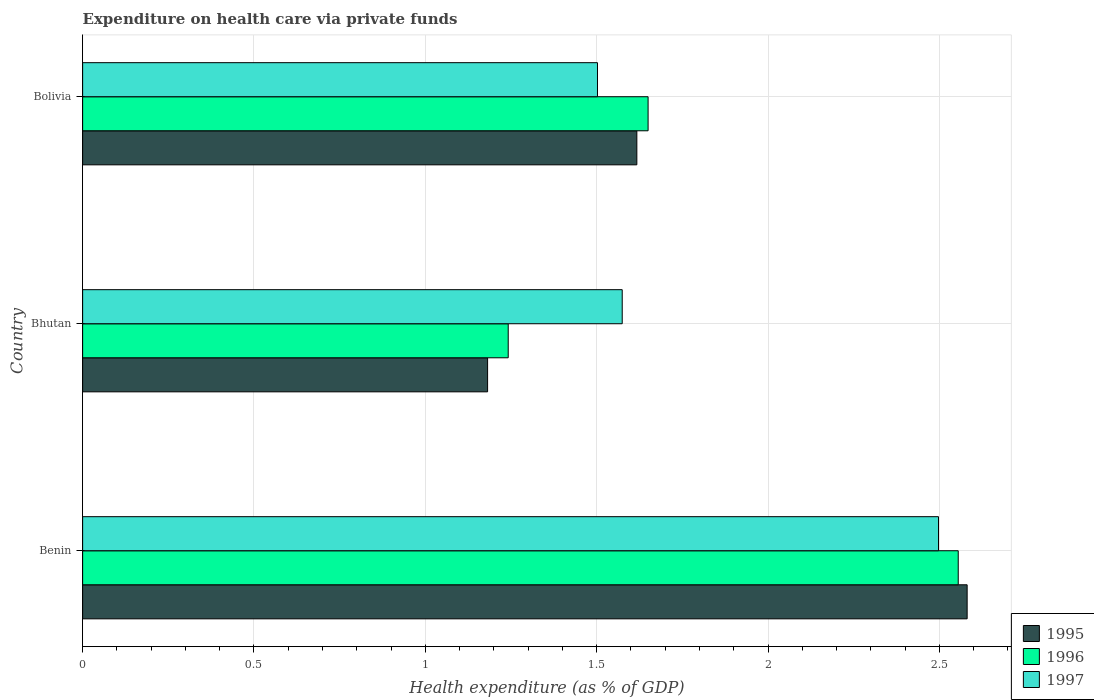How many different coloured bars are there?
Give a very brief answer. 3. How many groups of bars are there?
Your answer should be very brief. 3. Are the number of bars on each tick of the Y-axis equal?
Provide a succinct answer. Yes. How many bars are there on the 3rd tick from the bottom?
Keep it short and to the point. 3. What is the label of the 3rd group of bars from the top?
Ensure brevity in your answer.  Benin. In how many cases, is the number of bars for a given country not equal to the number of legend labels?
Provide a short and direct response. 0. What is the expenditure made on health care in 1995 in Bhutan?
Make the answer very short. 1.18. Across all countries, what is the maximum expenditure made on health care in 1997?
Ensure brevity in your answer.  2.5. Across all countries, what is the minimum expenditure made on health care in 1996?
Make the answer very short. 1.24. In which country was the expenditure made on health care in 1997 maximum?
Keep it short and to the point. Benin. In which country was the expenditure made on health care in 1995 minimum?
Provide a short and direct response. Bhutan. What is the total expenditure made on health care in 1996 in the graph?
Keep it short and to the point. 5.45. What is the difference between the expenditure made on health care in 1996 in Benin and that in Bolivia?
Provide a short and direct response. 0.9. What is the difference between the expenditure made on health care in 1996 in Bhutan and the expenditure made on health care in 1995 in Benin?
Provide a short and direct response. -1.34. What is the average expenditure made on health care in 1995 per country?
Give a very brief answer. 1.79. What is the difference between the expenditure made on health care in 1995 and expenditure made on health care in 1996 in Bhutan?
Provide a short and direct response. -0.06. What is the ratio of the expenditure made on health care in 1997 in Bhutan to that in Bolivia?
Ensure brevity in your answer.  1.05. Is the difference between the expenditure made on health care in 1995 in Benin and Bhutan greater than the difference between the expenditure made on health care in 1996 in Benin and Bhutan?
Offer a very short reply. Yes. What is the difference between the highest and the second highest expenditure made on health care in 1996?
Provide a short and direct response. 0.9. What is the difference between the highest and the lowest expenditure made on health care in 1997?
Make the answer very short. 1. In how many countries, is the expenditure made on health care in 1997 greater than the average expenditure made on health care in 1997 taken over all countries?
Give a very brief answer. 1. Is the sum of the expenditure made on health care in 1996 in Benin and Bhutan greater than the maximum expenditure made on health care in 1997 across all countries?
Keep it short and to the point. Yes. What does the 3rd bar from the bottom in Bolivia represents?
Your answer should be very brief. 1997. Is it the case that in every country, the sum of the expenditure made on health care in 1997 and expenditure made on health care in 1995 is greater than the expenditure made on health care in 1996?
Ensure brevity in your answer.  Yes. How many bars are there?
Offer a terse response. 9. Are all the bars in the graph horizontal?
Keep it short and to the point. Yes. Are the values on the major ticks of X-axis written in scientific E-notation?
Your response must be concise. No. Where does the legend appear in the graph?
Ensure brevity in your answer.  Bottom right. How many legend labels are there?
Give a very brief answer. 3. How are the legend labels stacked?
Your response must be concise. Vertical. What is the title of the graph?
Offer a very short reply. Expenditure on health care via private funds. Does "1992" appear as one of the legend labels in the graph?
Provide a short and direct response. No. What is the label or title of the X-axis?
Make the answer very short. Health expenditure (as % of GDP). What is the label or title of the Y-axis?
Ensure brevity in your answer.  Country. What is the Health expenditure (as % of GDP) of 1995 in Benin?
Your response must be concise. 2.58. What is the Health expenditure (as % of GDP) of 1996 in Benin?
Your answer should be very brief. 2.55. What is the Health expenditure (as % of GDP) in 1997 in Benin?
Give a very brief answer. 2.5. What is the Health expenditure (as % of GDP) of 1995 in Bhutan?
Ensure brevity in your answer.  1.18. What is the Health expenditure (as % of GDP) of 1996 in Bhutan?
Offer a very short reply. 1.24. What is the Health expenditure (as % of GDP) in 1997 in Bhutan?
Provide a succinct answer. 1.57. What is the Health expenditure (as % of GDP) of 1995 in Bolivia?
Ensure brevity in your answer.  1.62. What is the Health expenditure (as % of GDP) in 1996 in Bolivia?
Your response must be concise. 1.65. What is the Health expenditure (as % of GDP) of 1997 in Bolivia?
Your answer should be compact. 1.5. Across all countries, what is the maximum Health expenditure (as % of GDP) in 1995?
Give a very brief answer. 2.58. Across all countries, what is the maximum Health expenditure (as % of GDP) of 1996?
Provide a short and direct response. 2.55. Across all countries, what is the maximum Health expenditure (as % of GDP) of 1997?
Keep it short and to the point. 2.5. Across all countries, what is the minimum Health expenditure (as % of GDP) in 1995?
Keep it short and to the point. 1.18. Across all countries, what is the minimum Health expenditure (as % of GDP) in 1996?
Keep it short and to the point. 1.24. Across all countries, what is the minimum Health expenditure (as % of GDP) in 1997?
Your answer should be compact. 1.5. What is the total Health expenditure (as % of GDP) of 1995 in the graph?
Offer a terse response. 5.38. What is the total Health expenditure (as % of GDP) of 1996 in the graph?
Offer a very short reply. 5.45. What is the total Health expenditure (as % of GDP) of 1997 in the graph?
Your answer should be very brief. 5.57. What is the difference between the Health expenditure (as % of GDP) of 1995 in Benin and that in Bhutan?
Offer a very short reply. 1.4. What is the difference between the Health expenditure (as % of GDP) in 1996 in Benin and that in Bhutan?
Offer a terse response. 1.31. What is the difference between the Health expenditure (as % of GDP) of 1997 in Benin and that in Bhutan?
Offer a terse response. 0.92. What is the difference between the Health expenditure (as % of GDP) in 1995 in Benin and that in Bolivia?
Keep it short and to the point. 0.96. What is the difference between the Health expenditure (as % of GDP) of 1996 in Benin and that in Bolivia?
Provide a short and direct response. 0.91. What is the difference between the Health expenditure (as % of GDP) in 1997 in Benin and that in Bolivia?
Keep it short and to the point. 1. What is the difference between the Health expenditure (as % of GDP) in 1995 in Bhutan and that in Bolivia?
Provide a short and direct response. -0.44. What is the difference between the Health expenditure (as % of GDP) in 1996 in Bhutan and that in Bolivia?
Keep it short and to the point. -0.41. What is the difference between the Health expenditure (as % of GDP) in 1997 in Bhutan and that in Bolivia?
Your answer should be very brief. 0.07. What is the difference between the Health expenditure (as % of GDP) in 1995 in Benin and the Health expenditure (as % of GDP) in 1996 in Bhutan?
Offer a terse response. 1.34. What is the difference between the Health expenditure (as % of GDP) of 1996 in Benin and the Health expenditure (as % of GDP) of 1997 in Bhutan?
Provide a short and direct response. 0.98. What is the difference between the Health expenditure (as % of GDP) of 1995 in Benin and the Health expenditure (as % of GDP) of 1997 in Bolivia?
Give a very brief answer. 1.08. What is the difference between the Health expenditure (as % of GDP) of 1996 in Benin and the Health expenditure (as % of GDP) of 1997 in Bolivia?
Offer a very short reply. 1.05. What is the difference between the Health expenditure (as % of GDP) in 1995 in Bhutan and the Health expenditure (as % of GDP) in 1996 in Bolivia?
Ensure brevity in your answer.  -0.47. What is the difference between the Health expenditure (as % of GDP) in 1995 in Bhutan and the Health expenditure (as % of GDP) in 1997 in Bolivia?
Offer a very short reply. -0.32. What is the difference between the Health expenditure (as % of GDP) of 1996 in Bhutan and the Health expenditure (as % of GDP) of 1997 in Bolivia?
Your answer should be very brief. -0.26. What is the average Health expenditure (as % of GDP) of 1995 per country?
Your answer should be compact. 1.79. What is the average Health expenditure (as % of GDP) in 1996 per country?
Your answer should be compact. 1.82. What is the average Health expenditure (as % of GDP) in 1997 per country?
Give a very brief answer. 1.86. What is the difference between the Health expenditure (as % of GDP) of 1995 and Health expenditure (as % of GDP) of 1996 in Benin?
Provide a succinct answer. 0.03. What is the difference between the Health expenditure (as % of GDP) in 1995 and Health expenditure (as % of GDP) in 1997 in Benin?
Offer a terse response. 0.08. What is the difference between the Health expenditure (as % of GDP) in 1996 and Health expenditure (as % of GDP) in 1997 in Benin?
Provide a succinct answer. 0.06. What is the difference between the Health expenditure (as % of GDP) of 1995 and Health expenditure (as % of GDP) of 1996 in Bhutan?
Your answer should be compact. -0.06. What is the difference between the Health expenditure (as % of GDP) of 1995 and Health expenditure (as % of GDP) of 1997 in Bhutan?
Give a very brief answer. -0.39. What is the difference between the Health expenditure (as % of GDP) of 1996 and Health expenditure (as % of GDP) of 1997 in Bhutan?
Offer a terse response. -0.33. What is the difference between the Health expenditure (as % of GDP) of 1995 and Health expenditure (as % of GDP) of 1996 in Bolivia?
Give a very brief answer. -0.03. What is the difference between the Health expenditure (as % of GDP) of 1995 and Health expenditure (as % of GDP) of 1997 in Bolivia?
Provide a short and direct response. 0.11. What is the difference between the Health expenditure (as % of GDP) of 1996 and Health expenditure (as % of GDP) of 1997 in Bolivia?
Your answer should be compact. 0.15. What is the ratio of the Health expenditure (as % of GDP) of 1995 in Benin to that in Bhutan?
Provide a succinct answer. 2.18. What is the ratio of the Health expenditure (as % of GDP) of 1996 in Benin to that in Bhutan?
Your answer should be very brief. 2.06. What is the ratio of the Health expenditure (as % of GDP) of 1997 in Benin to that in Bhutan?
Ensure brevity in your answer.  1.59. What is the ratio of the Health expenditure (as % of GDP) of 1995 in Benin to that in Bolivia?
Your answer should be compact. 1.6. What is the ratio of the Health expenditure (as % of GDP) of 1996 in Benin to that in Bolivia?
Make the answer very short. 1.55. What is the ratio of the Health expenditure (as % of GDP) of 1997 in Benin to that in Bolivia?
Offer a very short reply. 1.66. What is the ratio of the Health expenditure (as % of GDP) of 1995 in Bhutan to that in Bolivia?
Make the answer very short. 0.73. What is the ratio of the Health expenditure (as % of GDP) of 1996 in Bhutan to that in Bolivia?
Keep it short and to the point. 0.75. What is the ratio of the Health expenditure (as % of GDP) of 1997 in Bhutan to that in Bolivia?
Make the answer very short. 1.05. What is the difference between the highest and the second highest Health expenditure (as % of GDP) of 1995?
Provide a succinct answer. 0.96. What is the difference between the highest and the second highest Health expenditure (as % of GDP) in 1996?
Your response must be concise. 0.91. What is the difference between the highest and the second highest Health expenditure (as % of GDP) of 1997?
Your response must be concise. 0.92. What is the difference between the highest and the lowest Health expenditure (as % of GDP) in 1995?
Your answer should be very brief. 1.4. What is the difference between the highest and the lowest Health expenditure (as % of GDP) of 1996?
Your answer should be very brief. 1.31. 